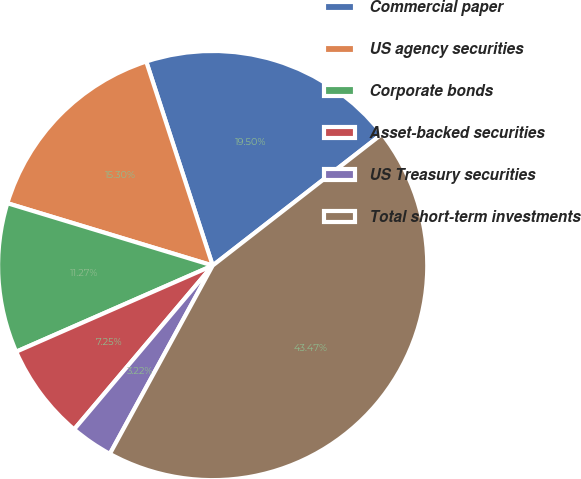Convert chart. <chart><loc_0><loc_0><loc_500><loc_500><pie_chart><fcel>Commercial paper<fcel>US agency securities<fcel>Corporate bonds<fcel>Asset-backed securities<fcel>US Treasury securities<fcel>Total short-term investments<nl><fcel>19.5%<fcel>15.3%<fcel>11.27%<fcel>7.25%<fcel>3.22%<fcel>43.47%<nl></chart> 